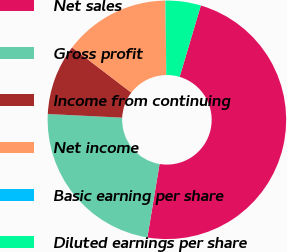Convert chart. <chart><loc_0><loc_0><loc_500><loc_500><pie_chart><fcel>Net sales<fcel>Gross profit<fcel>Income from continuing<fcel>Net income<fcel>Basic earning per share<fcel>Diluted earnings per share<nl><fcel>48.03%<fcel>23.16%<fcel>9.61%<fcel>14.41%<fcel>0.0%<fcel>4.8%<nl></chart> 